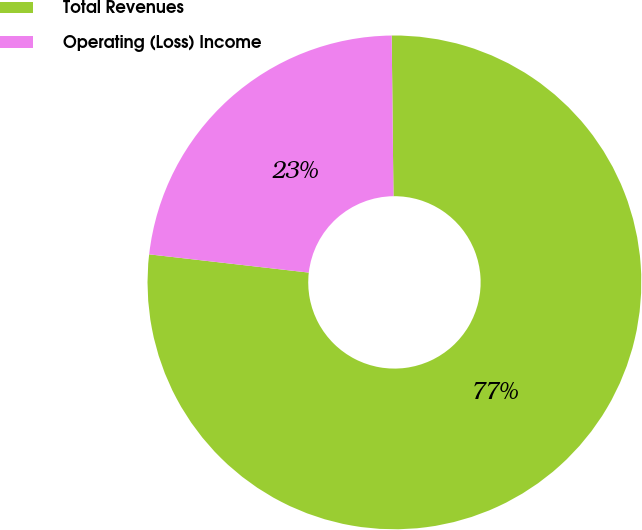<chart> <loc_0><loc_0><loc_500><loc_500><pie_chart><fcel>Total Revenues<fcel>Operating (Loss) Income<nl><fcel>76.99%<fcel>23.01%<nl></chart> 